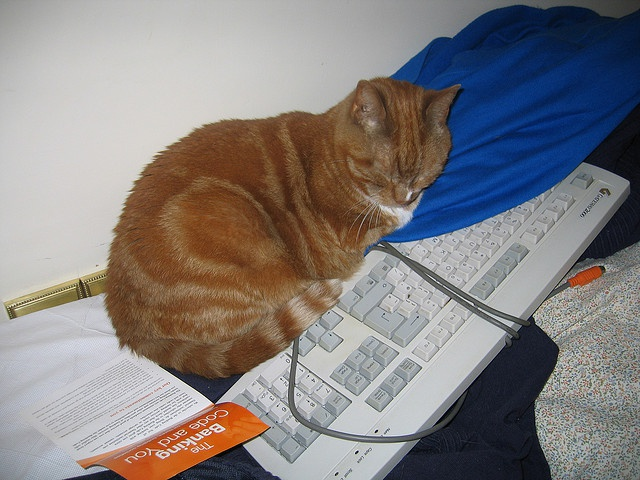Describe the objects in this image and their specific colors. I can see cat in gray, maroon, and brown tones and keyboard in gray, darkgray, and lightgray tones in this image. 